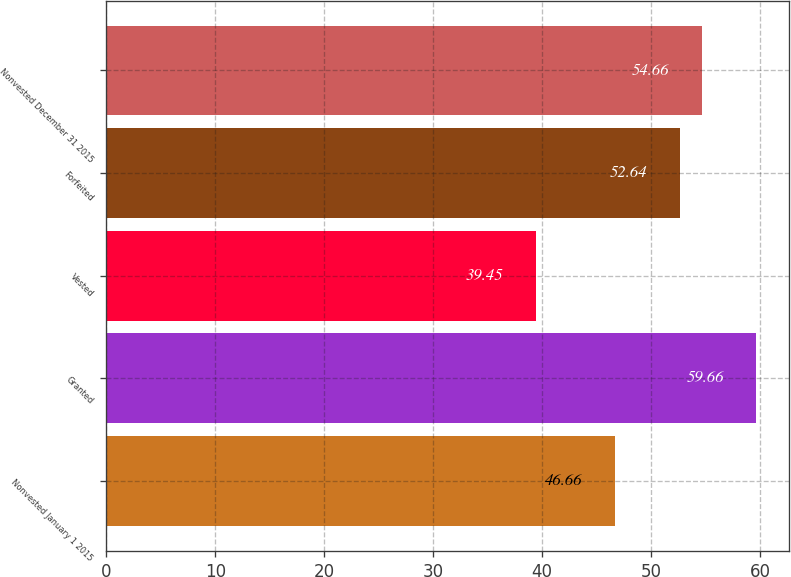Convert chart to OTSL. <chart><loc_0><loc_0><loc_500><loc_500><bar_chart><fcel>Nonvested January 1 2015<fcel>Granted<fcel>Vested<fcel>Forfeited<fcel>Nonvested December 31 2015<nl><fcel>46.66<fcel>59.66<fcel>39.45<fcel>52.64<fcel>54.66<nl></chart> 